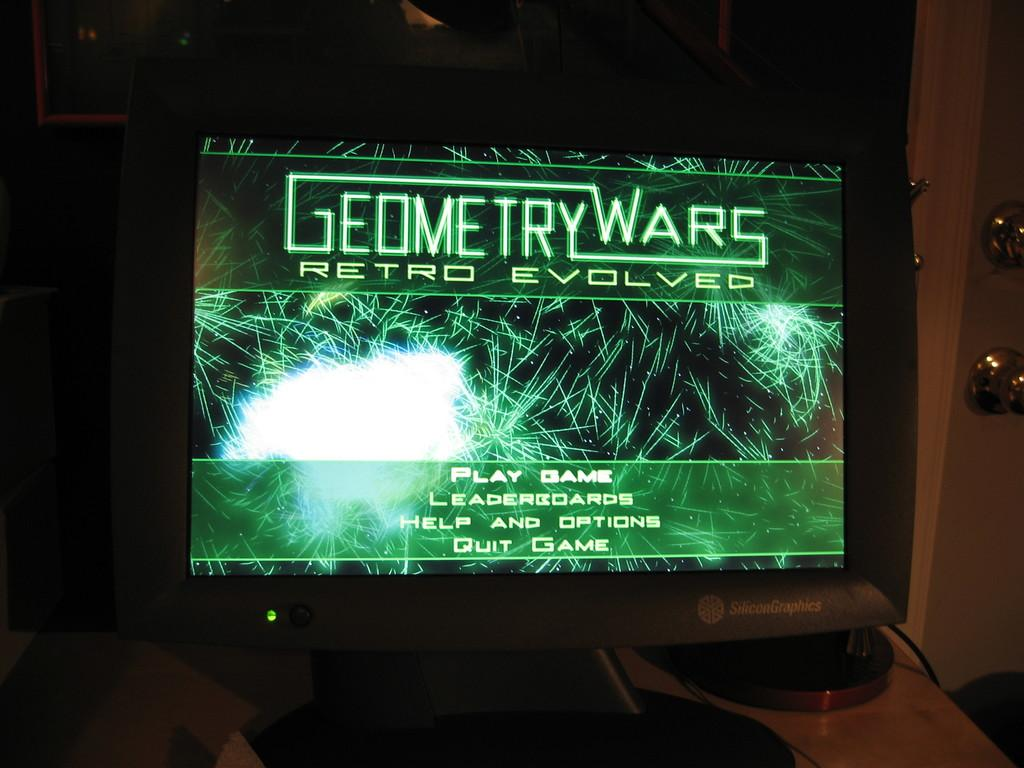<image>
Offer a succinct explanation of the picture presented. A screenshot of the start screen for Geometry Wars Retro Evolved. 